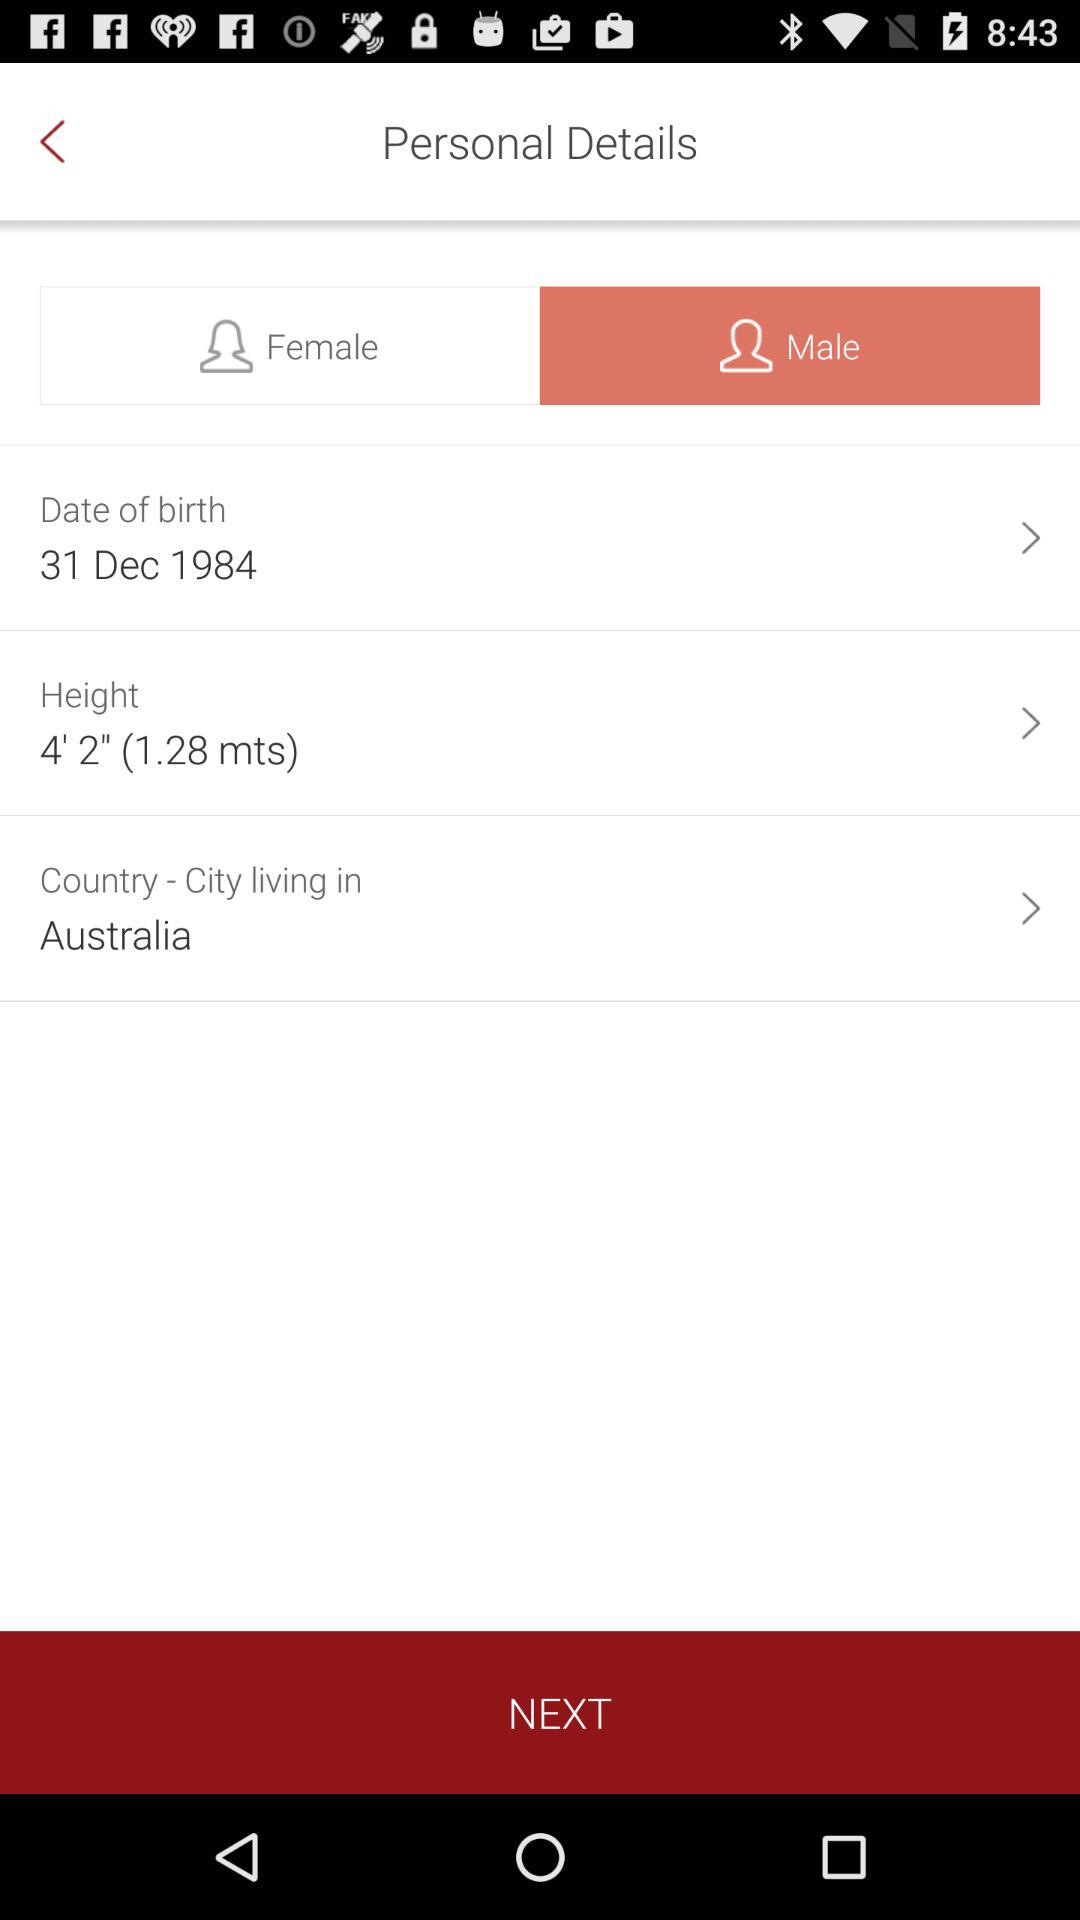What is the date of birth? The date of birth is December 31st, 1984. 